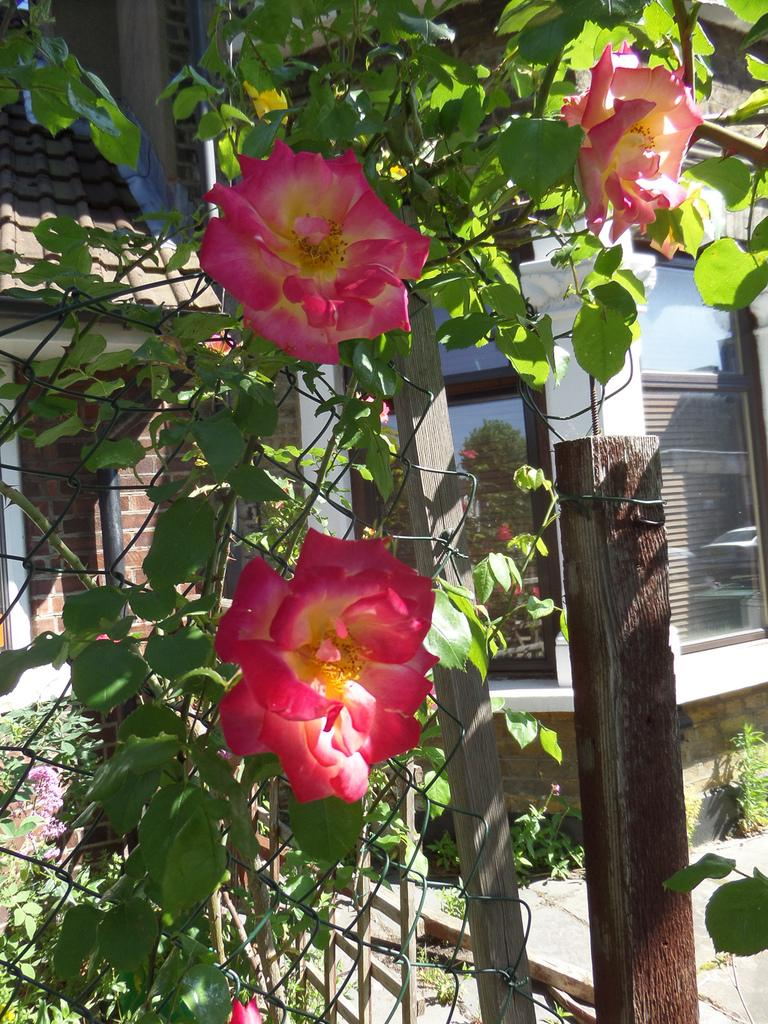What type of living organisms can be seen in the image? There are flowers in the image, which are associated with plants. What can be seen in the background of the image? There is a building visible in the background of the image. Can you list the swimming techniques used by the flowers in the image? There are no swimming techniques used by the flowers in the image, as flowers are not capable of swimming. 